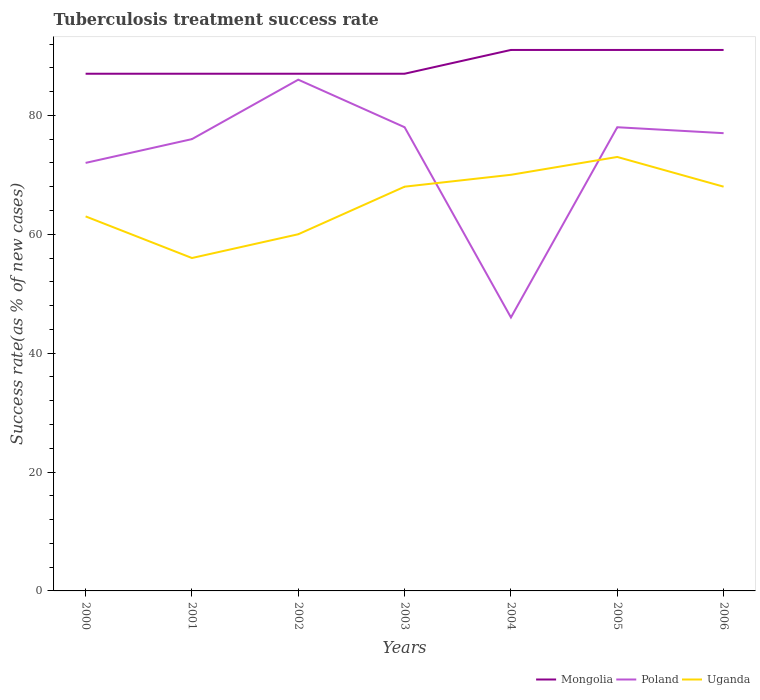Does the line corresponding to Mongolia intersect with the line corresponding to Uganda?
Ensure brevity in your answer.  No. What is the total tuberculosis treatment success rate in Uganda in the graph?
Provide a short and direct response. -5. What is the difference between the highest and the lowest tuberculosis treatment success rate in Poland?
Provide a succinct answer. 5. Is the tuberculosis treatment success rate in Uganda strictly greater than the tuberculosis treatment success rate in Poland over the years?
Offer a terse response. No. How many lines are there?
Offer a very short reply. 3. How many years are there in the graph?
Make the answer very short. 7. What is the difference between two consecutive major ticks on the Y-axis?
Make the answer very short. 20. Does the graph contain any zero values?
Provide a succinct answer. No. Does the graph contain grids?
Provide a short and direct response. No. Where does the legend appear in the graph?
Your response must be concise. Bottom right. How many legend labels are there?
Offer a terse response. 3. What is the title of the graph?
Keep it short and to the point. Tuberculosis treatment success rate. What is the label or title of the Y-axis?
Offer a very short reply. Success rate(as % of new cases). What is the Success rate(as % of new cases) in Mongolia in 2000?
Give a very brief answer. 87. What is the Success rate(as % of new cases) in Uganda in 2000?
Provide a succinct answer. 63. What is the Success rate(as % of new cases) of Mongolia in 2001?
Your response must be concise. 87. What is the Success rate(as % of new cases) in Poland in 2001?
Keep it short and to the point. 76. What is the Success rate(as % of new cases) in Uganda in 2001?
Provide a succinct answer. 56. What is the Success rate(as % of new cases) of Poland in 2002?
Make the answer very short. 86. What is the Success rate(as % of new cases) of Mongolia in 2003?
Your answer should be compact. 87. What is the Success rate(as % of new cases) in Uganda in 2003?
Offer a terse response. 68. What is the Success rate(as % of new cases) of Mongolia in 2004?
Offer a terse response. 91. What is the Success rate(as % of new cases) in Mongolia in 2005?
Your response must be concise. 91. What is the Success rate(as % of new cases) in Poland in 2005?
Your response must be concise. 78. What is the Success rate(as % of new cases) in Uganda in 2005?
Your answer should be compact. 73. What is the Success rate(as % of new cases) in Mongolia in 2006?
Keep it short and to the point. 91. What is the Success rate(as % of new cases) of Poland in 2006?
Offer a very short reply. 77. Across all years, what is the maximum Success rate(as % of new cases) in Mongolia?
Give a very brief answer. 91. Across all years, what is the minimum Success rate(as % of new cases) in Mongolia?
Your answer should be compact. 87. Across all years, what is the minimum Success rate(as % of new cases) of Uganda?
Offer a terse response. 56. What is the total Success rate(as % of new cases) in Mongolia in the graph?
Provide a succinct answer. 621. What is the total Success rate(as % of new cases) of Poland in the graph?
Your answer should be very brief. 513. What is the total Success rate(as % of new cases) of Uganda in the graph?
Give a very brief answer. 458. What is the difference between the Success rate(as % of new cases) in Mongolia in 2000 and that in 2001?
Offer a very short reply. 0. What is the difference between the Success rate(as % of new cases) in Poland in 2000 and that in 2001?
Give a very brief answer. -4. What is the difference between the Success rate(as % of new cases) of Mongolia in 2000 and that in 2002?
Offer a terse response. 0. What is the difference between the Success rate(as % of new cases) in Uganda in 2000 and that in 2002?
Make the answer very short. 3. What is the difference between the Success rate(as % of new cases) in Mongolia in 2000 and that in 2003?
Keep it short and to the point. 0. What is the difference between the Success rate(as % of new cases) in Mongolia in 2000 and that in 2004?
Your answer should be compact. -4. What is the difference between the Success rate(as % of new cases) in Mongolia in 2000 and that in 2005?
Give a very brief answer. -4. What is the difference between the Success rate(as % of new cases) of Uganda in 2000 and that in 2005?
Keep it short and to the point. -10. What is the difference between the Success rate(as % of new cases) of Mongolia in 2001 and that in 2002?
Provide a succinct answer. 0. What is the difference between the Success rate(as % of new cases) in Poland in 2001 and that in 2002?
Your answer should be very brief. -10. What is the difference between the Success rate(as % of new cases) in Uganda in 2001 and that in 2002?
Ensure brevity in your answer.  -4. What is the difference between the Success rate(as % of new cases) of Mongolia in 2001 and that in 2003?
Your answer should be compact. 0. What is the difference between the Success rate(as % of new cases) of Mongolia in 2001 and that in 2005?
Make the answer very short. -4. What is the difference between the Success rate(as % of new cases) in Poland in 2001 and that in 2005?
Provide a short and direct response. -2. What is the difference between the Success rate(as % of new cases) of Mongolia in 2001 and that in 2006?
Provide a succinct answer. -4. What is the difference between the Success rate(as % of new cases) of Poland in 2002 and that in 2003?
Ensure brevity in your answer.  8. What is the difference between the Success rate(as % of new cases) of Uganda in 2002 and that in 2003?
Your answer should be very brief. -8. What is the difference between the Success rate(as % of new cases) of Mongolia in 2002 and that in 2004?
Keep it short and to the point. -4. What is the difference between the Success rate(as % of new cases) of Mongolia in 2002 and that in 2005?
Ensure brevity in your answer.  -4. What is the difference between the Success rate(as % of new cases) of Poland in 2002 and that in 2005?
Your answer should be compact. 8. What is the difference between the Success rate(as % of new cases) of Uganda in 2002 and that in 2005?
Your response must be concise. -13. What is the difference between the Success rate(as % of new cases) in Poland in 2002 and that in 2006?
Offer a very short reply. 9. What is the difference between the Success rate(as % of new cases) in Uganda in 2002 and that in 2006?
Offer a terse response. -8. What is the difference between the Success rate(as % of new cases) in Mongolia in 2003 and that in 2004?
Provide a short and direct response. -4. What is the difference between the Success rate(as % of new cases) in Mongolia in 2003 and that in 2005?
Make the answer very short. -4. What is the difference between the Success rate(as % of new cases) in Poland in 2003 and that in 2005?
Your response must be concise. 0. What is the difference between the Success rate(as % of new cases) in Uganda in 2003 and that in 2005?
Make the answer very short. -5. What is the difference between the Success rate(as % of new cases) of Mongolia in 2003 and that in 2006?
Ensure brevity in your answer.  -4. What is the difference between the Success rate(as % of new cases) in Mongolia in 2004 and that in 2005?
Offer a terse response. 0. What is the difference between the Success rate(as % of new cases) of Poland in 2004 and that in 2005?
Provide a succinct answer. -32. What is the difference between the Success rate(as % of new cases) of Uganda in 2004 and that in 2005?
Make the answer very short. -3. What is the difference between the Success rate(as % of new cases) of Poland in 2004 and that in 2006?
Make the answer very short. -31. What is the difference between the Success rate(as % of new cases) of Uganda in 2004 and that in 2006?
Keep it short and to the point. 2. What is the difference between the Success rate(as % of new cases) of Mongolia in 2005 and that in 2006?
Provide a succinct answer. 0. What is the difference between the Success rate(as % of new cases) in Poland in 2005 and that in 2006?
Provide a succinct answer. 1. What is the difference between the Success rate(as % of new cases) in Uganda in 2005 and that in 2006?
Give a very brief answer. 5. What is the difference between the Success rate(as % of new cases) of Mongolia in 2000 and the Success rate(as % of new cases) of Poland in 2001?
Your answer should be compact. 11. What is the difference between the Success rate(as % of new cases) in Poland in 2000 and the Success rate(as % of new cases) in Uganda in 2001?
Offer a terse response. 16. What is the difference between the Success rate(as % of new cases) in Mongolia in 2000 and the Success rate(as % of new cases) in Poland in 2002?
Provide a succinct answer. 1. What is the difference between the Success rate(as % of new cases) of Poland in 2000 and the Success rate(as % of new cases) of Uganda in 2002?
Offer a terse response. 12. What is the difference between the Success rate(as % of new cases) in Mongolia in 2000 and the Success rate(as % of new cases) in Poland in 2003?
Offer a terse response. 9. What is the difference between the Success rate(as % of new cases) of Mongolia in 2000 and the Success rate(as % of new cases) of Uganda in 2003?
Ensure brevity in your answer.  19. What is the difference between the Success rate(as % of new cases) in Poland in 2000 and the Success rate(as % of new cases) in Uganda in 2003?
Give a very brief answer. 4. What is the difference between the Success rate(as % of new cases) of Mongolia in 2000 and the Success rate(as % of new cases) of Poland in 2004?
Give a very brief answer. 41. What is the difference between the Success rate(as % of new cases) in Mongolia in 2000 and the Success rate(as % of new cases) in Uganda in 2005?
Offer a terse response. 14. What is the difference between the Success rate(as % of new cases) of Mongolia in 2000 and the Success rate(as % of new cases) of Poland in 2006?
Provide a short and direct response. 10. What is the difference between the Success rate(as % of new cases) of Mongolia in 2000 and the Success rate(as % of new cases) of Uganda in 2006?
Keep it short and to the point. 19. What is the difference between the Success rate(as % of new cases) of Poland in 2000 and the Success rate(as % of new cases) of Uganda in 2006?
Make the answer very short. 4. What is the difference between the Success rate(as % of new cases) in Mongolia in 2001 and the Success rate(as % of new cases) in Uganda in 2002?
Your answer should be very brief. 27. What is the difference between the Success rate(as % of new cases) of Poland in 2001 and the Success rate(as % of new cases) of Uganda in 2002?
Provide a short and direct response. 16. What is the difference between the Success rate(as % of new cases) in Mongolia in 2001 and the Success rate(as % of new cases) in Poland in 2003?
Keep it short and to the point. 9. What is the difference between the Success rate(as % of new cases) in Mongolia in 2001 and the Success rate(as % of new cases) in Uganda in 2003?
Make the answer very short. 19. What is the difference between the Success rate(as % of new cases) in Poland in 2001 and the Success rate(as % of new cases) in Uganda in 2003?
Your answer should be compact. 8. What is the difference between the Success rate(as % of new cases) of Mongolia in 2001 and the Success rate(as % of new cases) of Poland in 2005?
Provide a succinct answer. 9. What is the difference between the Success rate(as % of new cases) in Poland in 2001 and the Success rate(as % of new cases) in Uganda in 2005?
Ensure brevity in your answer.  3. What is the difference between the Success rate(as % of new cases) of Mongolia in 2001 and the Success rate(as % of new cases) of Poland in 2006?
Provide a short and direct response. 10. What is the difference between the Success rate(as % of new cases) in Mongolia in 2001 and the Success rate(as % of new cases) in Uganda in 2006?
Give a very brief answer. 19. What is the difference between the Success rate(as % of new cases) of Poland in 2001 and the Success rate(as % of new cases) of Uganda in 2006?
Provide a succinct answer. 8. What is the difference between the Success rate(as % of new cases) in Mongolia in 2002 and the Success rate(as % of new cases) in Uganda in 2003?
Give a very brief answer. 19. What is the difference between the Success rate(as % of new cases) of Poland in 2002 and the Success rate(as % of new cases) of Uganda in 2003?
Provide a succinct answer. 18. What is the difference between the Success rate(as % of new cases) of Mongolia in 2002 and the Success rate(as % of new cases) of Uganda in 2005?
Your answer should be compact. 14. What is the difference between the Success rate(as % of new cases) of Poland in 2002 and the Success rate(as % of new cases) of Uganda in 2005?
Your answer should be very brief. 13. What is the difference between the Success rate(as % of new cases) in Mongolia in 2003 and the Success rate(as % of new cases) in Poland in 2004?
Ensure brevity in your answer.  41. What is the difference between the Success rate(as % of new cases) of Mongolia in 2003 and the Success rate(as % of new cases) of Uganda in 2004?
Offer a very short reply. 17. What is the difference between the Success rate(as % of new cases) in Poland in 2003 and the Success rate(as % of new cases) in Uganda in 2004?
Provide a short and direct response. 8. What is the difference between the Success rate(as % of new cases) of Poland in 2004 and the Success rate(as % of new cases) of Uganda in 2005?
Make the answer very short. -27. What is the difference between the Success rate(as % of new cases) of Mongolia in 2004 and the Success rate(as % of new cases) of Uganda in 2006?
Your response must be concise. 23. What is the difference between the Success rate(as % of new cases) in Mongolia in 2005 and the Success rate(as % of new cases) in Uganda in 2006?
Ensure brevity in your answer.  23. What is the average Success rate(as % of new cases) of Mongolia per year?
Make the answer very short. 88.71. What is the average Success rate(as % of new cases) in Poland per year?
Ensure brevity in your answer.  73.29. What is the average Success rate(as % of new cases) of Uganda per year?
Make the answer very short. 65.43. In the year 2000, what is the difference between the Success rate(as % of new cases) in Poland and Success rate(as % of new cases) in Uganda?
Your answer should be compact. 9. In the year 2001, what is the difference between the Success rate(as % of new cases) of Mongolia and Success rate(as % of new cases) of Poland?
Offer a terse response. 11. In the year 2001, what is the difference between the Success rate(as % of new cases) in Poland and Success rate(as % of new cases) in Uganda?
Keep it short and to the point. 20. In the year 2002, what is the difference between the Success rate(as % of new cases) in Poland and Success rate(as % of new cases) in Uganda?
Give a very brief answer. 26. In the year 2003, what is the difference between the Success rate(as % of new cases) of Mongolia and Success rate(as % of new cases) of Uganda?
Offer a very short reply. 19. In the year 2003, what is the difference between the Success rate(as % of new cases) in Poland and Success rate(as % of new cases) in Uganda?
Your answer should be very brief. 10. In the year 2004, what is the difference between the Success rate(as % of new cases) in Mongolia and Success rate(as % of new cases) in Poland?
Offer a terse response. 45. In the year 2004, what is the difference between the Success rate(as % of new cases) in Mongolia and Success rate(as % of new cases) in Uganda?
Your answer should be very brief. 21. In the year 2005, what is the difference between the Success rate(as % of new cases) of Mongolia and Success rate(as % of new cases) of Poland?
Provide a short and direct response. 13. In the year 2005, what is the difference between the Success rate(as % of new cases) of Poland and Success rate(as % of new cases) of Uganda?
Provide a succinct answer. 5. In the year 2006, what is the difference between the Success rate(as % of new cases) of Mongolia and Success rate(as % of new cases) of Poland?
Provide a short and direct response. 14. In the year 2006, what is the difference between the Success rate(as % of new cases) of Mongolia and Success rate(as % of new cases) of Uganda?
Offer a very short reply. 23. What is the ratio of the Success rate(as % of new cases) of Poland in 2000 to that in 2001?
Keep it short and to the point. 0.95. What is the ratio of the Success rate(as % of new cases) of Uganda in 2000 to that in 2001?
Provide a short and direct response. 1.12. What is the ratio of the Success rate(as % of new cases) in Mongolia in 2000 to that in 2002?
Give a very brief answer. 1. What is the ratio of the Success rate(as % of new cases) of Poland in 2000 to that in 2002?
Make the answer very short. 0.84. What is the ratio of the Success rate(as % of new cases) of Uganda in 2000 to that in 2002?
Offer a very short reply. 1.05. What is the ratio of the Success rate(as % of new cases) of Uganda in 2000 to that in 2003?
Make the answer very short. 0.93. What is the ratio of the Success rate(as % of new cases) in Mongolia in 2000 to that in 2004?
Your answer should be compact. 0.96. What is the ratio of the Success rate(as % of new cases) in Poland in 2000 to that in 2004?
Ensure brevity in your answer.  1.57. What is the ratio of the Success rate(as % of new cases) in Uganda in 2000 to that in 2004?
Provide a short and direct response. 0.9. What is the ratio of the Success rate(as % of new cases) in Mongolia in 2000 to that in 2005?
Your answer should be very brief. 0.96. What is the ratio of the Success rate(as % of new cases) in Poland in 2000 to that in 2005?
Offer a terse response. 0.92. What is the ratio of the Success rate(as % of new cases) of Uganda in 2000 to that in 2005?
Offer a terse response. 0.86. What is the ratio of the Success rate(as % of new cases) of Mongolia in 2000 to that in 2006?
Provide a short and direct response. 0.96. What is the ratio of the Success rate(as % of new cases) in Poland in 2000 to that in 2006?
Your response must be concise. 0.94. What is the ratio of the Success rate(as % of new cases) of Uganda in 2000 to that in 2006?
Keep it short and to the point. 0.93. What is the ratio of the Success rate(as % of new cases) of Mongolia in 2001 to that in 2002?
Offer a terse response. 1. What is the ratio of the Success rate(as % of new cases) in Poland in 2001 to that in 2002?
Your answer should be very brief. 0.88. What is the ratio of the Success rate(as % of new cases) of Poland in 2001 to that in 2003?
Your answer should be very brief. 0.97. What is the ratio of the Success rate(as % of new cases) of Uganda in 2001 to that in 2003?
Offer a terse response. 0.82. What is the ratio of the Success rate(as % of new cases) in Mongolia in 2001 to that in 2004?
Provide a succinct answer. 0.96. What is the ratio of the Success rate(as % of new cases) of Poland in 2001 to that in 2004?
Make the answer very short. 1.65. What is the ratio of the Success rate(as % of new cases) of Mongolia in 2001 to that in 2005?
Give a very brief answer. 0.96. What is the ratio of the Success rate(as % of new cases) in Poland in 2001 to that in 2005?
Keep it short and to the point. 0.97. What is the ratio of the Success rate(as % of new cases) in Uganda in 2001 to that in 2005?
Your answer should be compact. 0.77. What is the ratio of the Success rate(as % of new cases) in Mongolia in 2001 to that in 2006?
Ensure brevity in your answer.  0.96. What is the ratio of the Success rate(as % of new cases) of Uganda in 2001 to that in 2006?
Provide a short and direct response. 0.82. What is the ratio of the Success rate(as % of new cases) in Mongolia in 2002 to that in 2003?
Keep it short and to the point. 1. What is the ratio of the Success rate(as % of new cases) in Poland in 2002 to that in 2003?
Offer a terse response. 1.1. What is the ratio of the Success rate(as % of new cases) of Uganda in 2002 to that in 2003?
Offer a very short reply. 0.88. What is the ratio of the Success rate(as % of new cases) in Mongolia in 2002 to that in 2004?
Provide a short and direct response. 0.96. What is the ratio of the Success rate(as % of new cases) of Poland in 2002 to that in 2004?
Provide a short and direct response. 1.87. What is the ratio of the Success rate(as % of new cases) of Uganda in 2002 to that in 2004?
Your answer should be very brief. 0.86. What is the ratio of the Success rate(as % of new cases) in Mongolia in 2002 to that in 2005?
Your response must be concise. 0.96. What is the ratio of the Success rate(as % of new cases) in Poland in 2002 to that in 2005?
Offer a terse response. 1.1. What is the ratio of the Success rate(as % of new cases) of Uganda in 2002 to that in 2005?
Make the answer very short. 0.82. What is the ratio of the Success rate(as % of new cases) of Mongolia in 2002 to that in 2006?
Your answer should be very brief. 0.96. What is the ratio of the Success rate(as % of new cases) in Poland in 2002 to that in 2006?
Provide a succinct answer. 1.12. What is the ratio of the Success rate(as % of new cases) of Uganda in 2002 to that in 2006?
Offer a very short reply. 0.88. What is the ratio of the Success rate(as % of new cases) of Mongolia in 2003 to that in 2004?
Your answer should be compact. 0.96. What is the ratio of the Success rate(as % of new cases) in Poland in 2003 to that in 2004?
Ensure brevity in your answer.  1.7. What is the ratio of the Success rate(as % of new cases) of Uganda in 2003 to that in 2004?
Your answer should be very brief. 0.97. What is the ratio of the Success rate(as % of new cases) of Mongolia in 2003 to that in 2005?
Give a very brief answer. 0.96. What is the ratio of the Success rate(as % of new cases) in Uganda in 2003 to that in 2005?
Your response must be concise. 0.93. What is the ratio of the Success rate(as % of new cases) in Mongolia in 2003 to that in 2006?
Your response must be concise. 0.96. What is the ratio of the Success rate(as % of new cases) in Uganda in 2003 to that in 2006?
Give a very brief answer. 1. What is the ratio of the Success rate(as % of new cases) of Poland in 2004 to that in 2005?
Give a very brief answer. 0.59. What is the ratio of the Success rate(as % of new cases) of Uganda in 2004 to that in 2005?
Keep it short and to the point. 0.96. What is the ratio of the Success rate(as % of new cases) of Mongolia in 2004 to that in 2006?
Offer a terse response. 1. What is the ratio of the Success rate(as % of new cases) in Poland in 2004 to that in 2006?
Offer a terse response. 0.6. What is the ratio of the Success rate(as % of new cases) of Uganda in 2004 to that in 2006?
Keep it short and to the point. 1.03. What is the ratio of the Success rate(as % of new cases) in Mongolia in 2005 to that in 2006?
Ensure brevity in your answer.  1. What is the ratio of the Success rate(as % of new cases) of Uganda in 2005 to that in 2006?
Keep it short and to the point. 1.07. What is the difference between the highest and the second highest Success rate(as % of new cases) in Mongolia?
Give a very brief answer. 0. What is the difference between the highest and the second highest Success rate(as % of new cases) in Poland?
Your answer should be very brief. 8. What is the difference between the highest and the lowest Success rate(as % of new cases) of Mongolia?
Offer a very short reply. 4. 